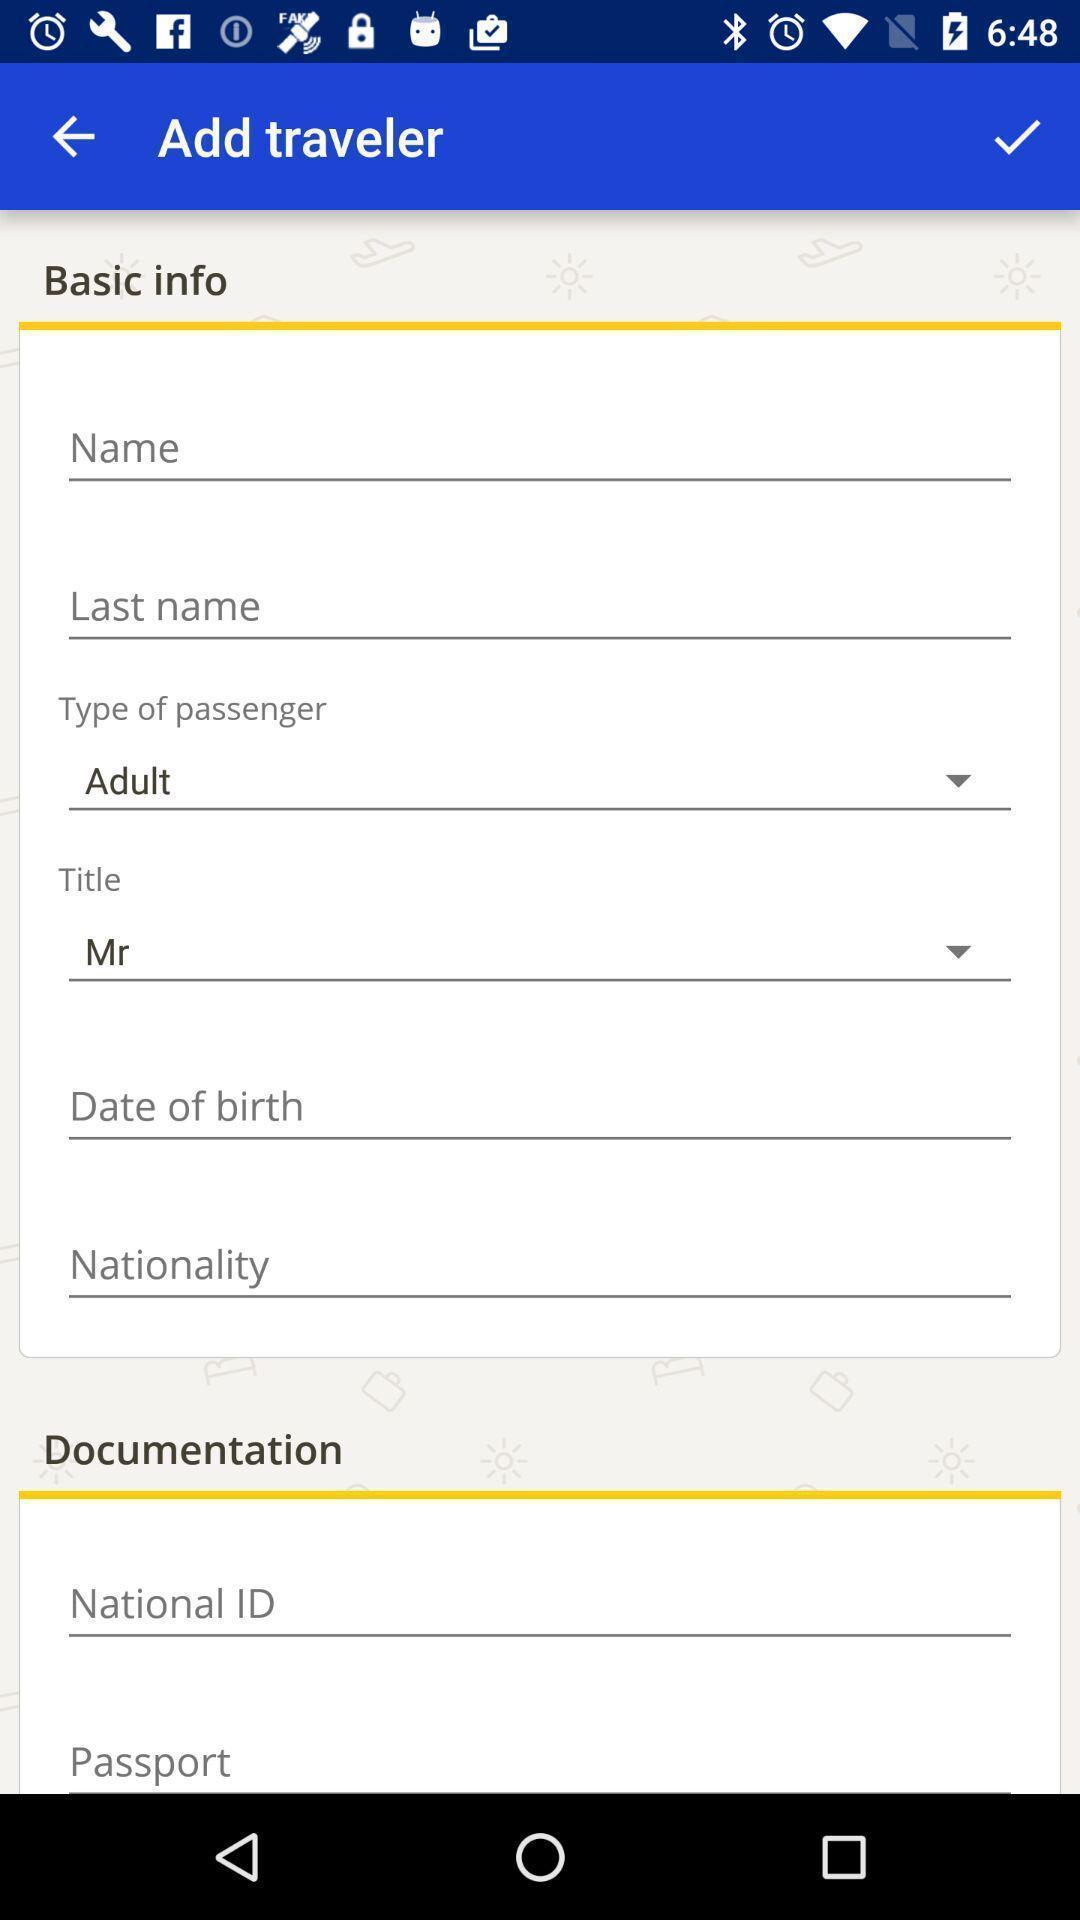Please provide a description for this image. Page to enter user information in a travel app. 